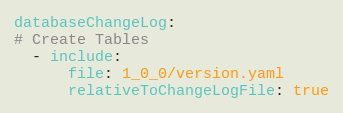<code> <loc_0><loc_0><loc_500><loc_500><_YAML_>databaseChangeLog:
# Create Tables
  - include:
      file: 1_0_0/version.yaml
      relativeToChangeLogFile: true</code> 